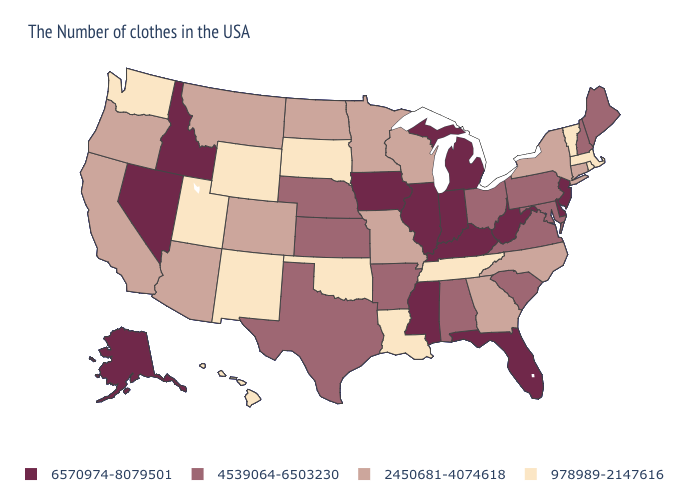Which states have the highest value in the USA?
Give a very brief answer. New Jersey, Delaware, West Virginia, Florida, Michigan, Kentucky, Indiana, Illinois, Mississippi, Iowa, Idaho, Nevada, Alaska. Does the first symbol in the legend represent the smallest category?
Give a very brief answer. No. Name the states that have a value in the range 978989-2147616?
Quick response, please. Massachusetts, Rhode Island, Vermont, Tennessee, Louisiana, Oklahoma, South Dakota, Wyoming, New Mexico, Utah, Washington, Hawaii. Which states hav the highest value in the MidWest?
Keep it brief. Michigan, Indiana, Illinois, Iowa. Does the first symbol in the legend represent the smallest category?
Keep it brief. No. What is the highest value in the MidWest ?
Short answer required. 6570974-8079501. What is the highest value in the USA?
Concise answer only. 6570974-8079501. What is the value of Mississippi?
Be succinct. 6570974-8079501. Does New Mexico have the same value as Delaware?
Quick response, please. No. What is the highest value in the West ?
Quick response, please. 6570974-8079501. Name the states that have a value in the range 4539064-6503230?
Be succinct. Maine, New Hampshire, Maryland, Pennsylvania, Virginia, South Carolina, Ohio, Alabama, Arkansas, Kansas, Nebraska, Texas. Among the states that border Alabama , which have the highest value?
Answer briefly. Florida, Mississippi. What is the value of Vermont?
Answer briefly. 978989-2147616. What is the value of Nevada?
Be succinct. 6570974-8079501. Is the legend a continuous bar?
Quick response, please. No. 